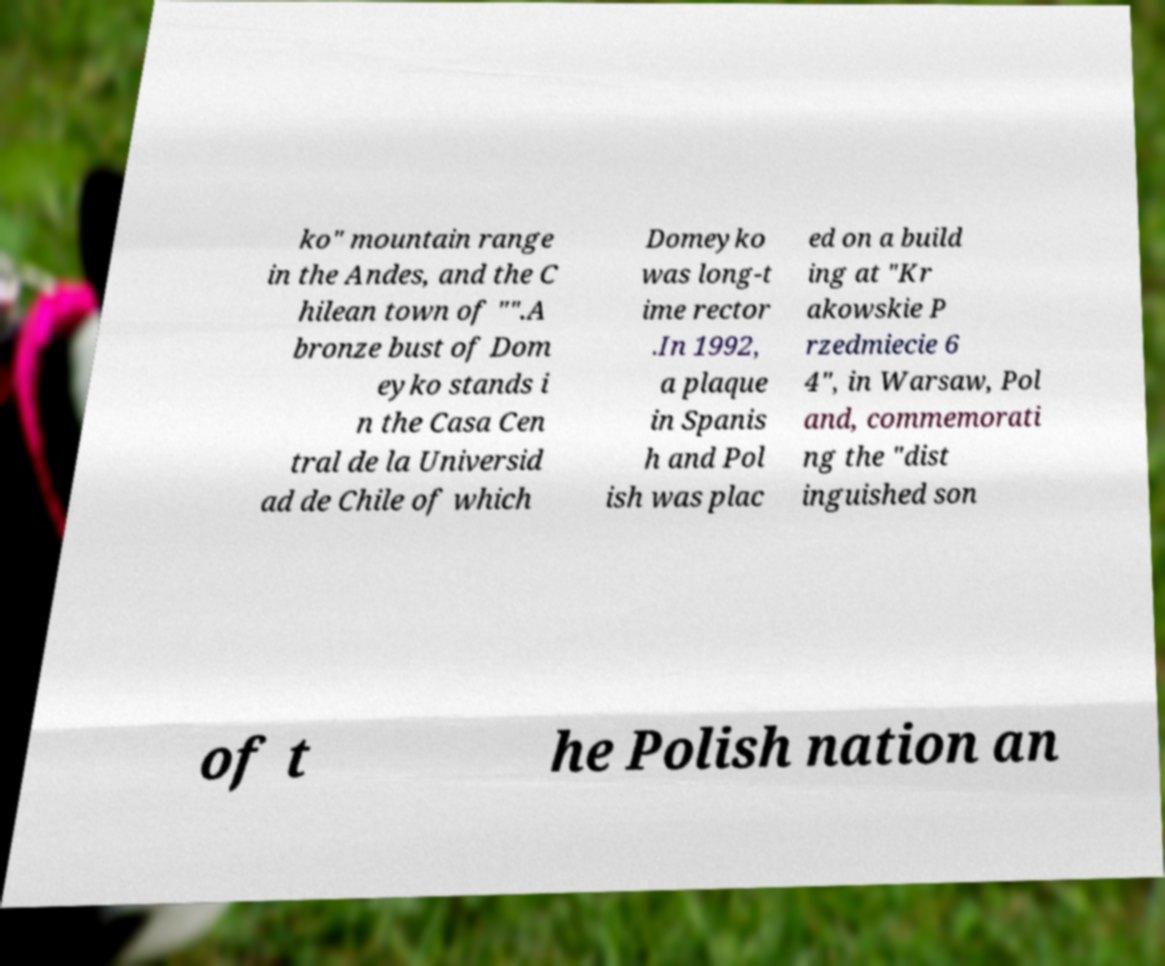Please read and relay the text visible in this image. What does it say? ko" mountain range in the Andes, and the C hilean town of "".A bronze bust of Dom eyko stands i n the Casa Cen tral de la Universid ad de Chile of which Domeyko was long-t ime rector .In 1992, a plaque in Spanis h and Pol ish was plac ed on a build ing at "Kr akowskie P rzedmiecie 6 4", in Warsaw, Pol and, commemorati ng the "dist inguished son of t he Polish nation an 